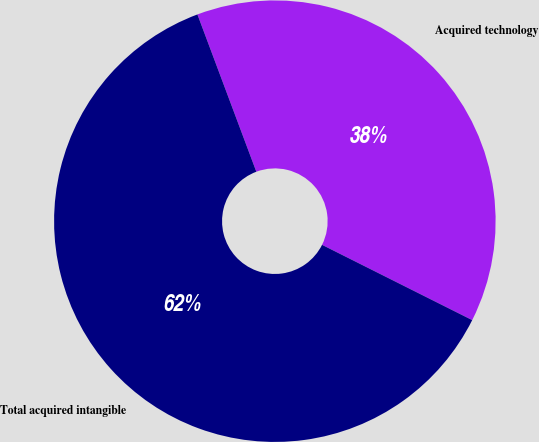Convert chart. <chart><loc_0><loc_0><loc_500><loc_500><pie_chart><fcel>Acquired technology<fcel>Total acquired intangible<nl><fcel>38.1%<fcel>61.9%<nl></chart> 